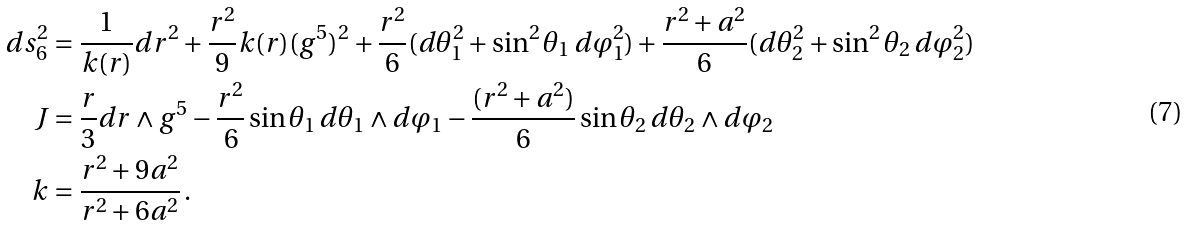Convert formula to latex. <formula><loc_0><loc_0><loc_500><loc_500>d s _ { 6 } ^ { 2 } & = \frac { 1 } { k ( r ) } d r ^ { 2 } + \frac { r ^ { 2 } } { 9 } k ( r ) ( g ^ { 5 } ) ^ { 2 } + \frac { r ^ { 2 } } { 6 } ( d \theta _ { 1 } ^ { 2 } + \sin ^ { 2 } \theta _ { 1 } \, d \varphi _ { 1 } ^ { 2 } ) + \frac { r ^ { 2 } + a ^ { 2 } } { 6 } ( d \theta _ { 2 } ^ { 2 } + \sin ^ { 2 } \theta _ { 2 } \, d \varphi _ { 2 } ^ { 2 } ) \\ J & = \frac { r } { 3 } d r \wedge g ^ { 5 } - \frac { r ^ { 2 } } { 6 } \sin \theta _ { 1 } \, d \theta _ { 1 } \wedge d \varphi _ { 1 } - \frac { ( r ^ { 2 } + a ^ { 2 } ) } { 6 } \sin \theta _ { 2 } \, d \theta _ { 2 } \wedge d \varphi _ { 2 } \\ k & = \frac { r ^ { 2 } + 9 a ^ { 2 } } { r ^ { 2 } + 6 a ^ { 2 } } \, .</formula> 